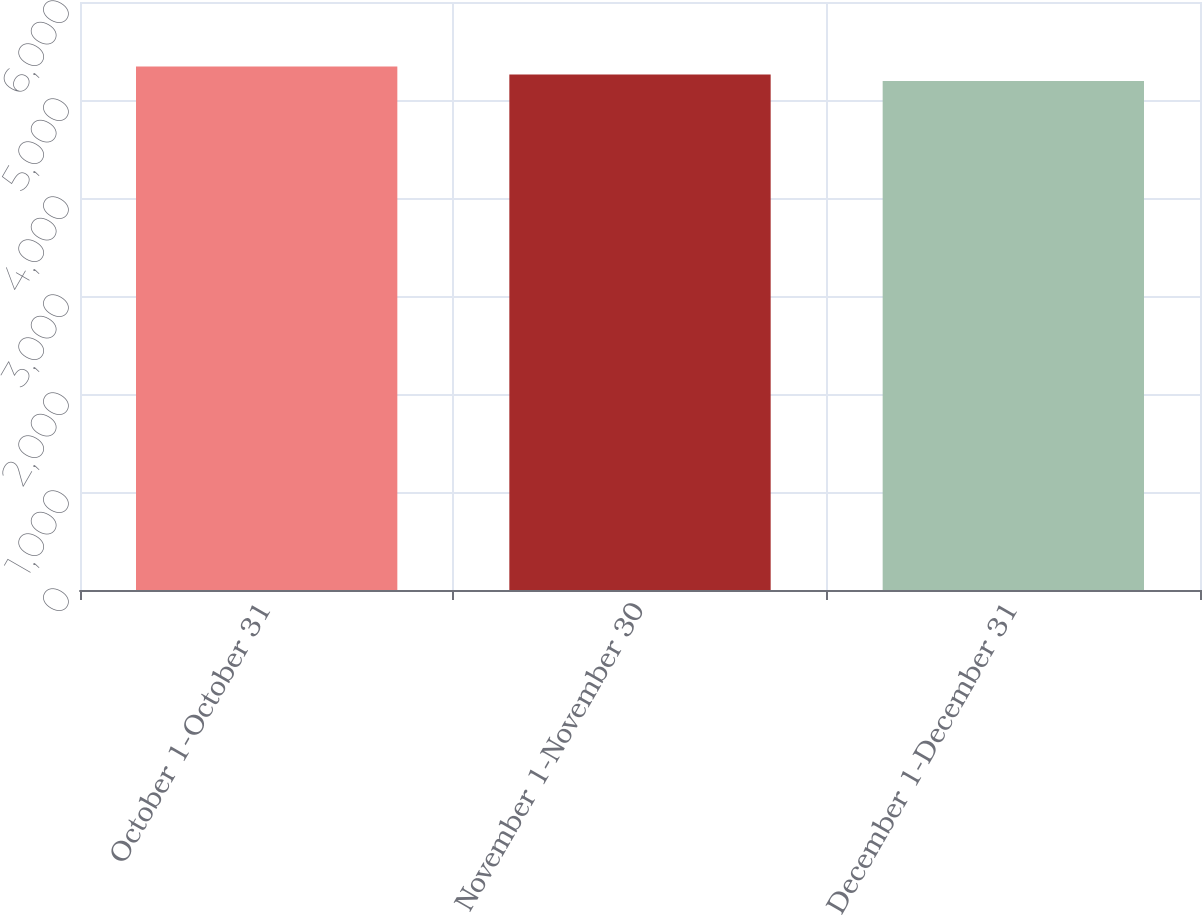<chart> <loc_0><loc_0><loc_500><loc_500><bar_chart><fcel>October 1-October 31<fcel>November 1-November 30<fcel>December 1-December 31<nl><fcel>5342<fcel>5259<fcel>5194<nl></chart> 